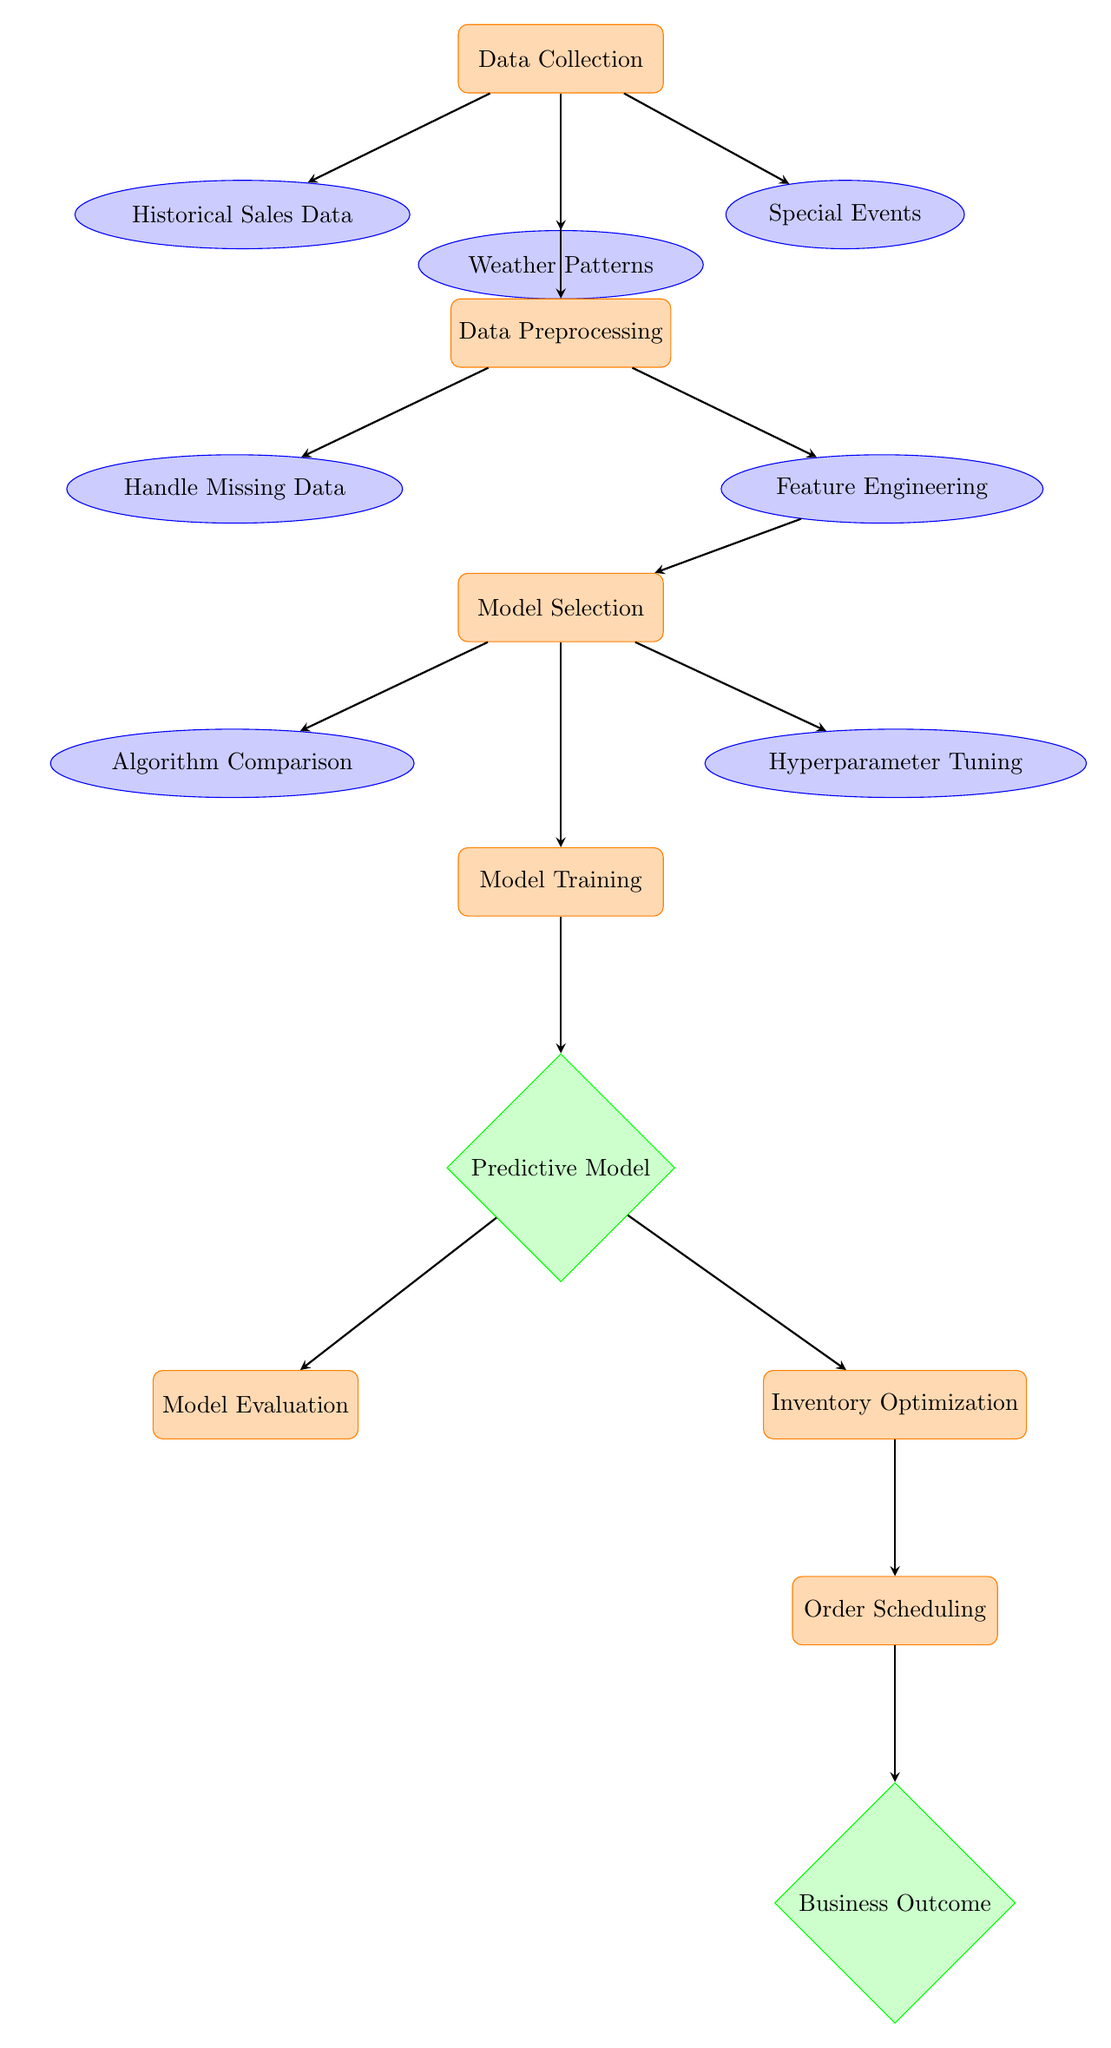What is the first step in the diagram? The first step is labeled as "Data Collection," which is the initial process before any data is analyzed or processed.
Answer: Data Collection How many data sources are identified in the diagram? There are three data sources identified: "Historical Sales Data," "Weather Patterns," and "Special Events." This count is from the connections directly below the "Data Collection" node.
Answer: Three What is the purpose of the "Model Evaluation" process? The "Model Evaluation" process serves to assess the predictive model developed earlier, determining how well it performs using appropriate evaluation metrics.
Answer: Assess model performance What happens after "Inventory Optimization"? After "Inventory Optimization," the next step is "Order Scheduling," indicating that successful optimization leads to scheduling orders for coffee beans appropriately.
Answer: Order Scheduling Which node directly precedes "Business Outcome"? The node that directly precedes "Business Outcome" is "Order Scheduling," so the data flow indicates that scheduling orders impacts the final business outcome.
Answer: Order Scheduling What type of node is "Predictive Model"? "Predictive Model" is categorized as a decision node, which signifies that it involves evaluating models to determine the optimal prediction approach for inventory.
Answer: Decision node How many processes are there in total? There are six processes in total within the diagram, which include "Data Collection," "Data Preprocessing," "Model Selection," "Model Training," "Model Evaluation," and "Inventory Optimization."
Answer: Six What is evaluated in the "Model Training" step? In the "Model Training" step, a model is fitted using the preprocessed data to enable it to make predictions on future inventory needs based on the inputs provided earlier.
Answer: Fitting a model What is the first data type encountered after "Data Collection"? The first data type encountered after "Data Collection" is "Historical Sales Data," which connects directly to the data collection process.
Answer: Historical Sales Data 